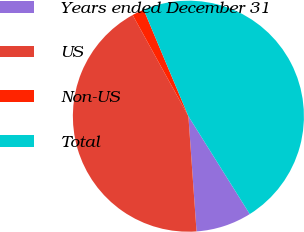<chart> <loc_0><loc_0><loc_500><loc_500><pie_chart><fcel>Years ended December 31<fcel>US<fcel>Non-US<fcel>Total<nl><fcel>7.79%<fcel>43.1%<fcel>1.69%<fcel>47.41%<nl></chart> 